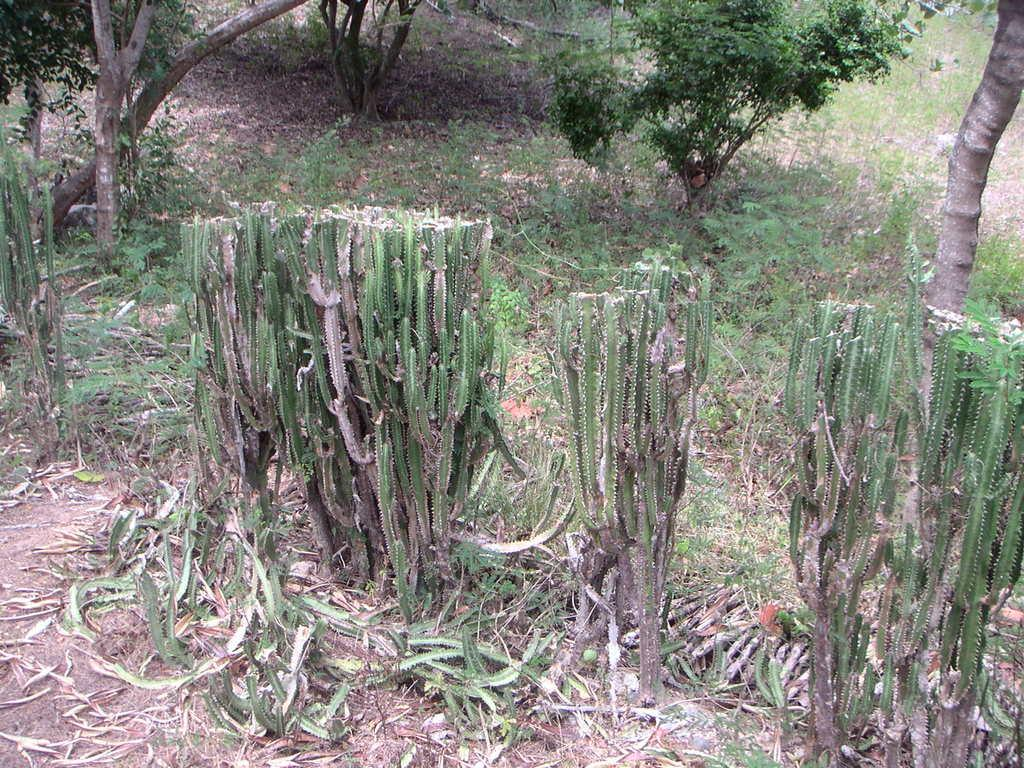What type of plants can be seen in the image? There are cactus plants in the image. What can be found on the ground in the image? There are dried leaves on the ground in the image. What part of a tree is visible in the image? The bark of a tree is visible in the image. What type of vegetation is present in the image? There are trees in the image. What type of quartz can be seen in the image? There is no quartz present in the image. What caused the dried leaves to fall on the ground in the image? The cause of the dried leaves falling on the ground is not visible or mentioned in the image. 